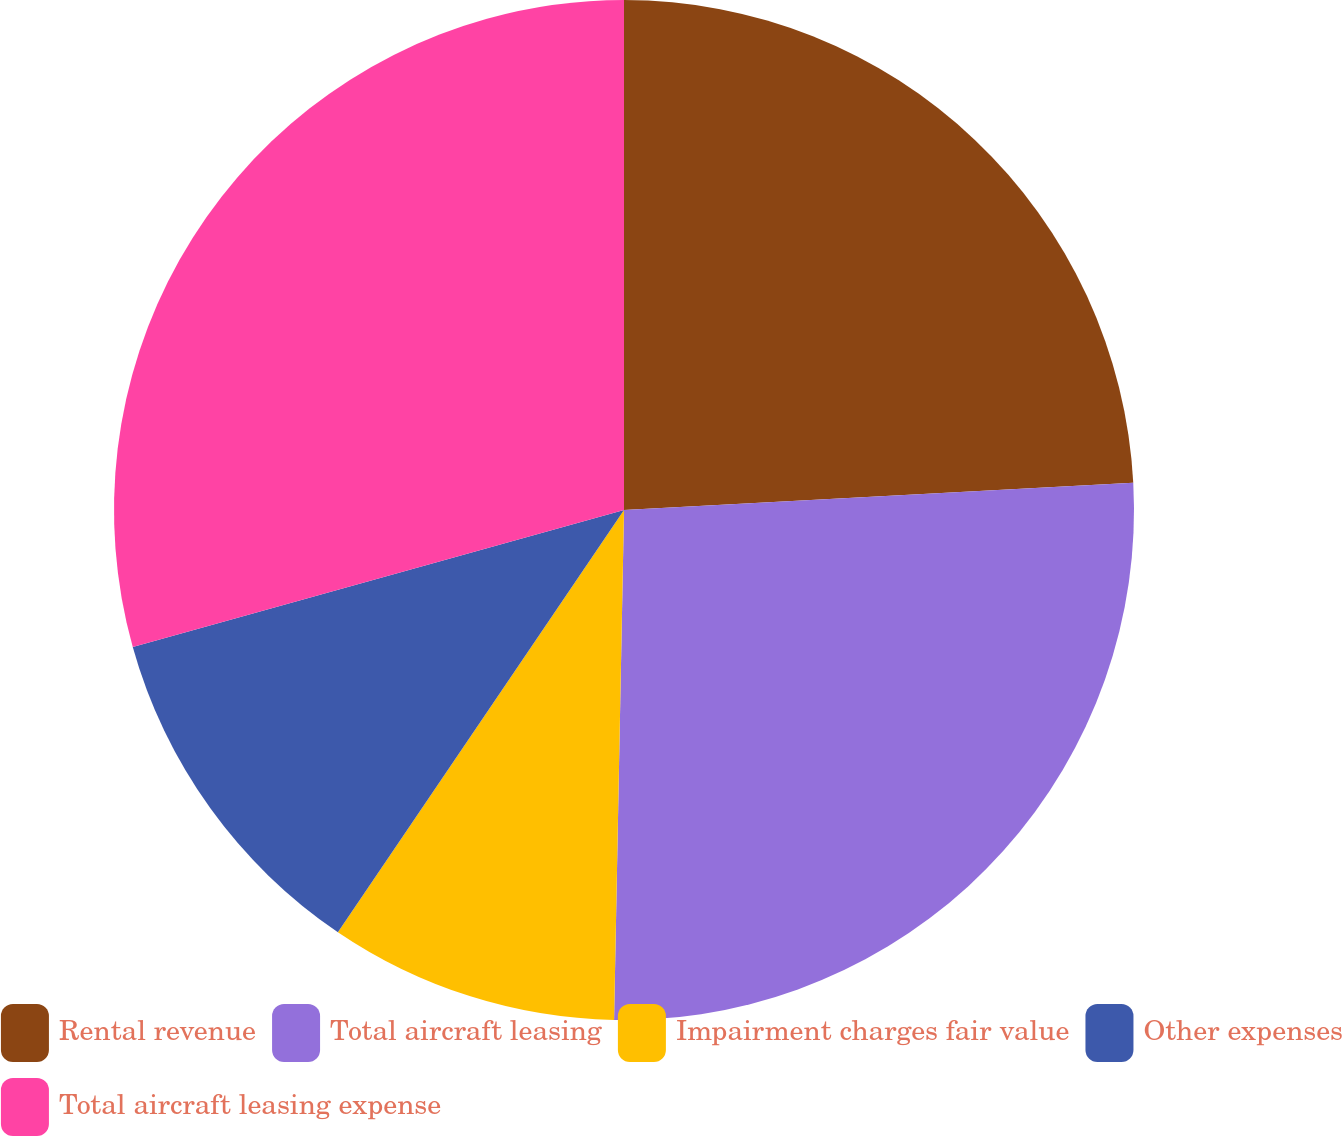Convert chart. <chart><loc_0><loc_0><loc_500><loc_500><pie_chart><fcel>Rental revenue<fcel>Total aircraft leasing<fcel>Impairment charges fair value<fcel>Other expenses<fcel>Total aircraft leasing expense<nl><fcel>24.15%<fcel>26.16%<fcel>9.17%<fcel>11.19%<fcel>29.33%<nl></chart> 